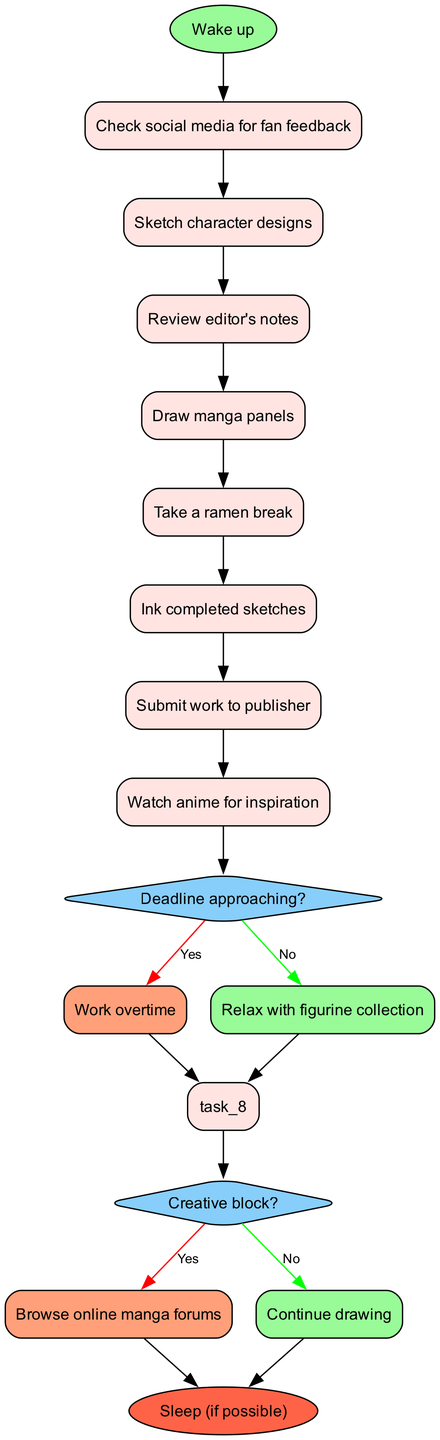What is the first task after waking up? The first task after waking up, as indicated in the diagram, is to "Check social media for fan feedback." This is directly linked to the start node.
Answer: Check social media for fan feedback How many decision points are in the routine? Upon analyzing the diagram, there are two decision points present that ask about the conditions regarding deadlines and creative blocks.
Answer: 2 What task follows "Sketch character designs"? The task that follows "Sketch character designs" is "Review editor's notes." The tasks are sequentially connected in the diagram.
Answer: Review editor's notes If the artist has a creative block, what is the next step? If the artist encounters a creative block, they are directed to "Browse online manga forums." This is a response path that follows the decision regarding the condition of the creative block.
Answer: Browse online manga forums What happens if the deadline is approaching and the artist works overtime? If the deadline is approaching and the artist decides to work overtime, the next action they will take is "Submit work to publisher," which leads to the end of the process.
Answer: Submit work to publisher Which task involves taking a break? The task that involves taking a break is "Take a ramen break." This is explicitly listed in the routine, indicating a moment of relaxation amidst tasks.
Answer: Take a ramen break What is the final node of the routine? The final node of the routine, as shown in the diagram, is "Sleep (if possible)." This represents the end of a manga artist's workday.
Answer: Sleep (if possible) What is the action following "Ink completed sketches"? After "Ink completed sketches," the artist moves to "Submit work to publisher." This indicates the progression in the workflow.
Answer: Submit work to publisher If a decision leads to "Relax with figurine collection," what condition was evaluated? The condition evaluated was "Deadline approaching?" If the answer is "No," the artist is directed to relax with their figurines.
Answer: Deadline approaching? 